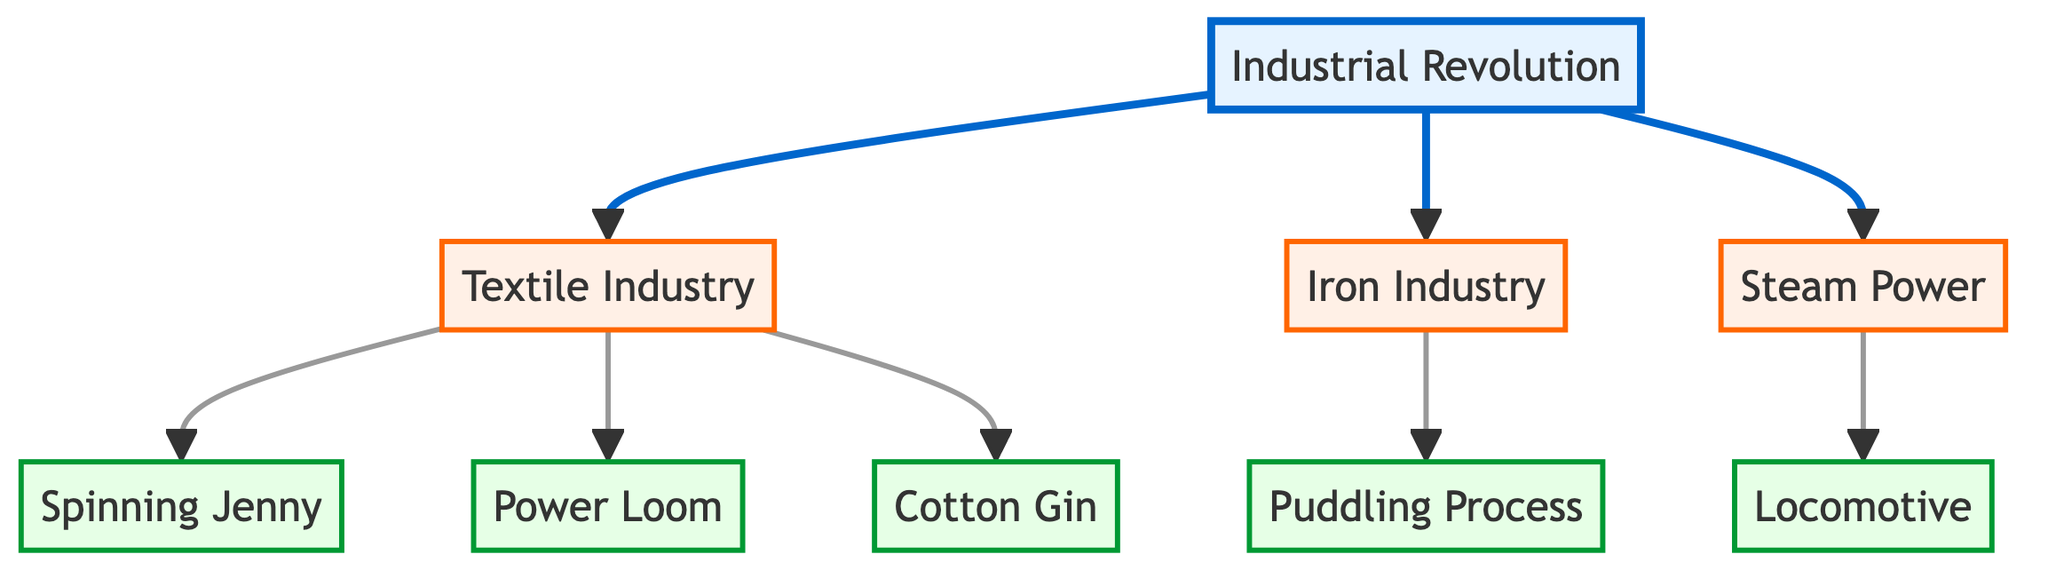What industries are influenced by the Industrial Revolution? The diagram shows three main industries influenced by the Industrial Revolution, which are the Textile Industry, Iron Industry, and Steam Power. Each of these industries is directly connected to the Industrial Revolution node.
Answer: Textile Industry, Iron Industry, Steam Power How many technological innovations are listed in the diagram? There are five technological innovations listed in the diagram: Spinning Jenny, Power Loom, Cotton Gin, Puddling Process, and Locomotive. Each innovation is connected to the relevant industry.
Answer: Five Which industry is connected to the Spinning Jenny? Looking at the edges in the diagram, the Spinning Jenny is connected to the Textile Industry, indicating its direct influence.
Answer: Textile Industry What is the relationship between the Iron Industry and the Puddling Process? The diagram indicates that the Puddling Process is a technological innovation specifically linked to the Iron Industry, thus showing a direct influence.
Answer: Puddling Process Which technological innovation is associated with Steam Power? The Locomotive is the specific innovation linked to Steam Power according to the connections shown in the diagram.
Answer: Locomotive How many edges are there in total? By counting the edges in the diagram, we see there are a total of seven edges that connect the nodes together, representing the relationships between industries and innovations.
Answer: Seven What innovation is connected to the Textile Industry that is not a loom? The Cotton Gin is connected to the Textile Industry and is not a loom (Power Loom), indicating an additional technological advancement in this field.
Answer: Cotton Gin Is the Iron Industry connected to any innovations related to steam? No, the Iron Industry is connected only to the Puddling Process, and no edges link it to steam-related innovations like the Locomotive or Steam Power.
Answer: No Which node does the Cotton Gin point to in the diagram? The Cotton Gin points to the Textile Industry node, indicating that it is a technological innovation specifically related to that industry.
Answer: Textile Industry 